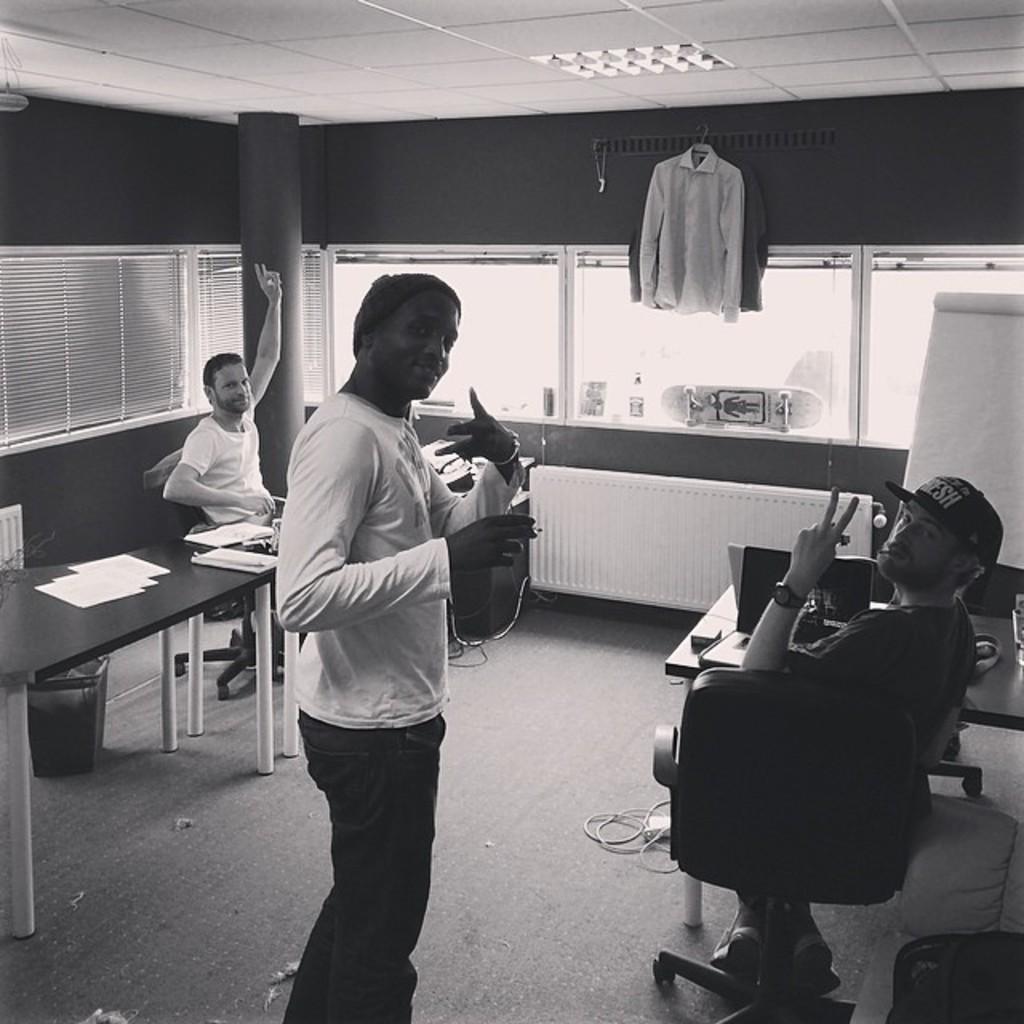Could you give a brief overview of what you see in this image? In front of the image there is a person standing, holding some object in his hand, in front of him there are two people sitting in chairs, in front of them on the tables there are some objects, in the room there are cables on the floor, trash can, room heater, board, in the background of the image there is a pillar, glass windows with curtains, at the top of the image there are clothes on a hanger. 